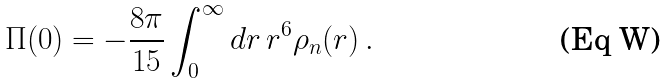<formula> <loc_0><loc_0><loc_500><loc_500>\Pi ( 0 ) = - \frac { 8 \pi } { 1 5 } \int _ { 0 } ^ { \infty } d r \, r ^ { 6 } \rho _ { n } ( r ) \, .</formula> 